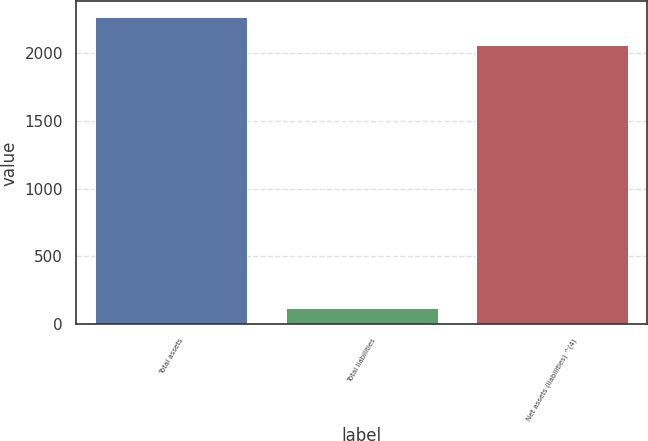<chart> <loc_0><loc_0><loc_500><loc_500><bar_chart><fcel>Total assets<fcel>Total liabilities<fcel>Net assets (liabilities) ^(4)<nl><fcel>2266<fcel>122<fcel>2060<nl></chart> 